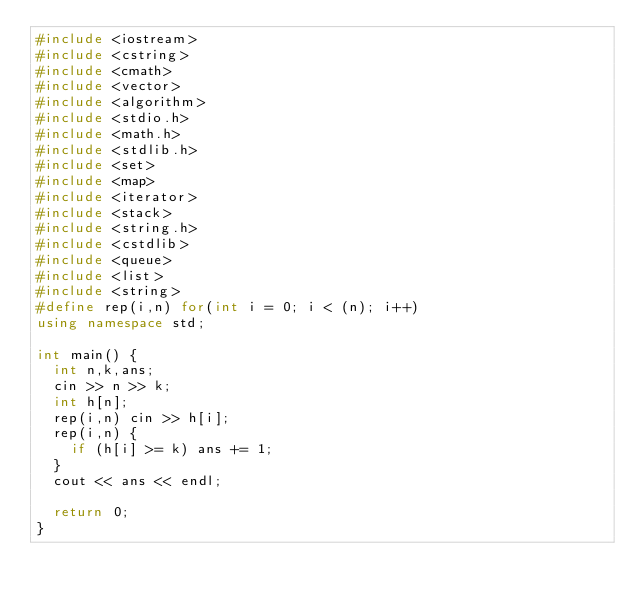Convert code to text. <code><loc_0><loc_0><loc_500><loc_500><_C++_>#include <iostream>
#include <cstring>
#include <cmath>
#include <vector>
#include <algorithm>
#include <stdio.h>
#include <math.h>
#include <stdlib.h>
#include <set>
#include <map>
#include <iterator>
#include <stack>
#include <string.h>
#include <cstdlib>
#include <queue>
#include <list>
#include <string>
#define rep(i,n) for(int i = 0; i < (n); i++) 
using namespace std;

int main() {
	int n,k,ans;
	cin >> n >> k;
	int h[n];
	rep(i,n) cin >> h[i];
	rep(i,n) {
		if (h[i] >= k) ans += 1;
	}
	cout << ans << endl;
	
	return 0;
}
</code> 